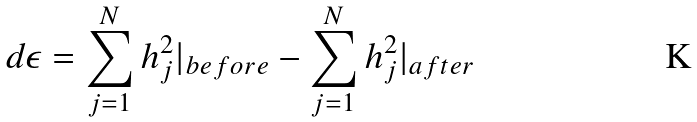<formula> <loc_0><loc_0><loc_500><loc_500>d \epsilon = \sum _ { j = 1 } ^ { N } h _ { j } ^ { 2 } | _ { b e f o r e } - \sum _ { j = 1 } ^ { N } h _ { j } ^ { 2 } | _ { a f t e r }</formula> 